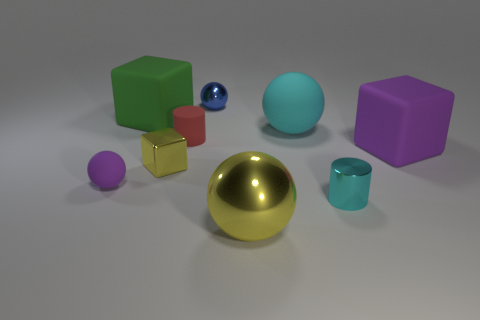What number of shiny things are either yellow blocks or small blue objects?
Your answer should be compact. 2. Is there a large metal cube?
Give a very brief answer. No. There is a large matte block left of the tiny cylinder that is to the left of the big cyan matte object; what is its color?
Provide a succinct answer. Green. How many other things are there of the same color as the large shiny thing?
Your answer should be very brief. 1. How many objects are either small cyan cylinders or metallic spheres behind the big purple rubber cube?
Offer a very short reply. 2. What is the color of the large object that is in front of the yellow cube?
Keep it short and to the point. Yellow. There is a tiny red object; what shape is it?
Give a very brief answer. Cylinder. The thing that is behind the large cube that is to the left of the red object is made of what material?
Offer a very short reply. Metal. What number of other objects are the same material as the small cyan cylinder?
Provide a succinct answer. 3. There is a ball that is the same size as the cyan matte thing; what is its material?
Keep it short and to the point. Metal. 